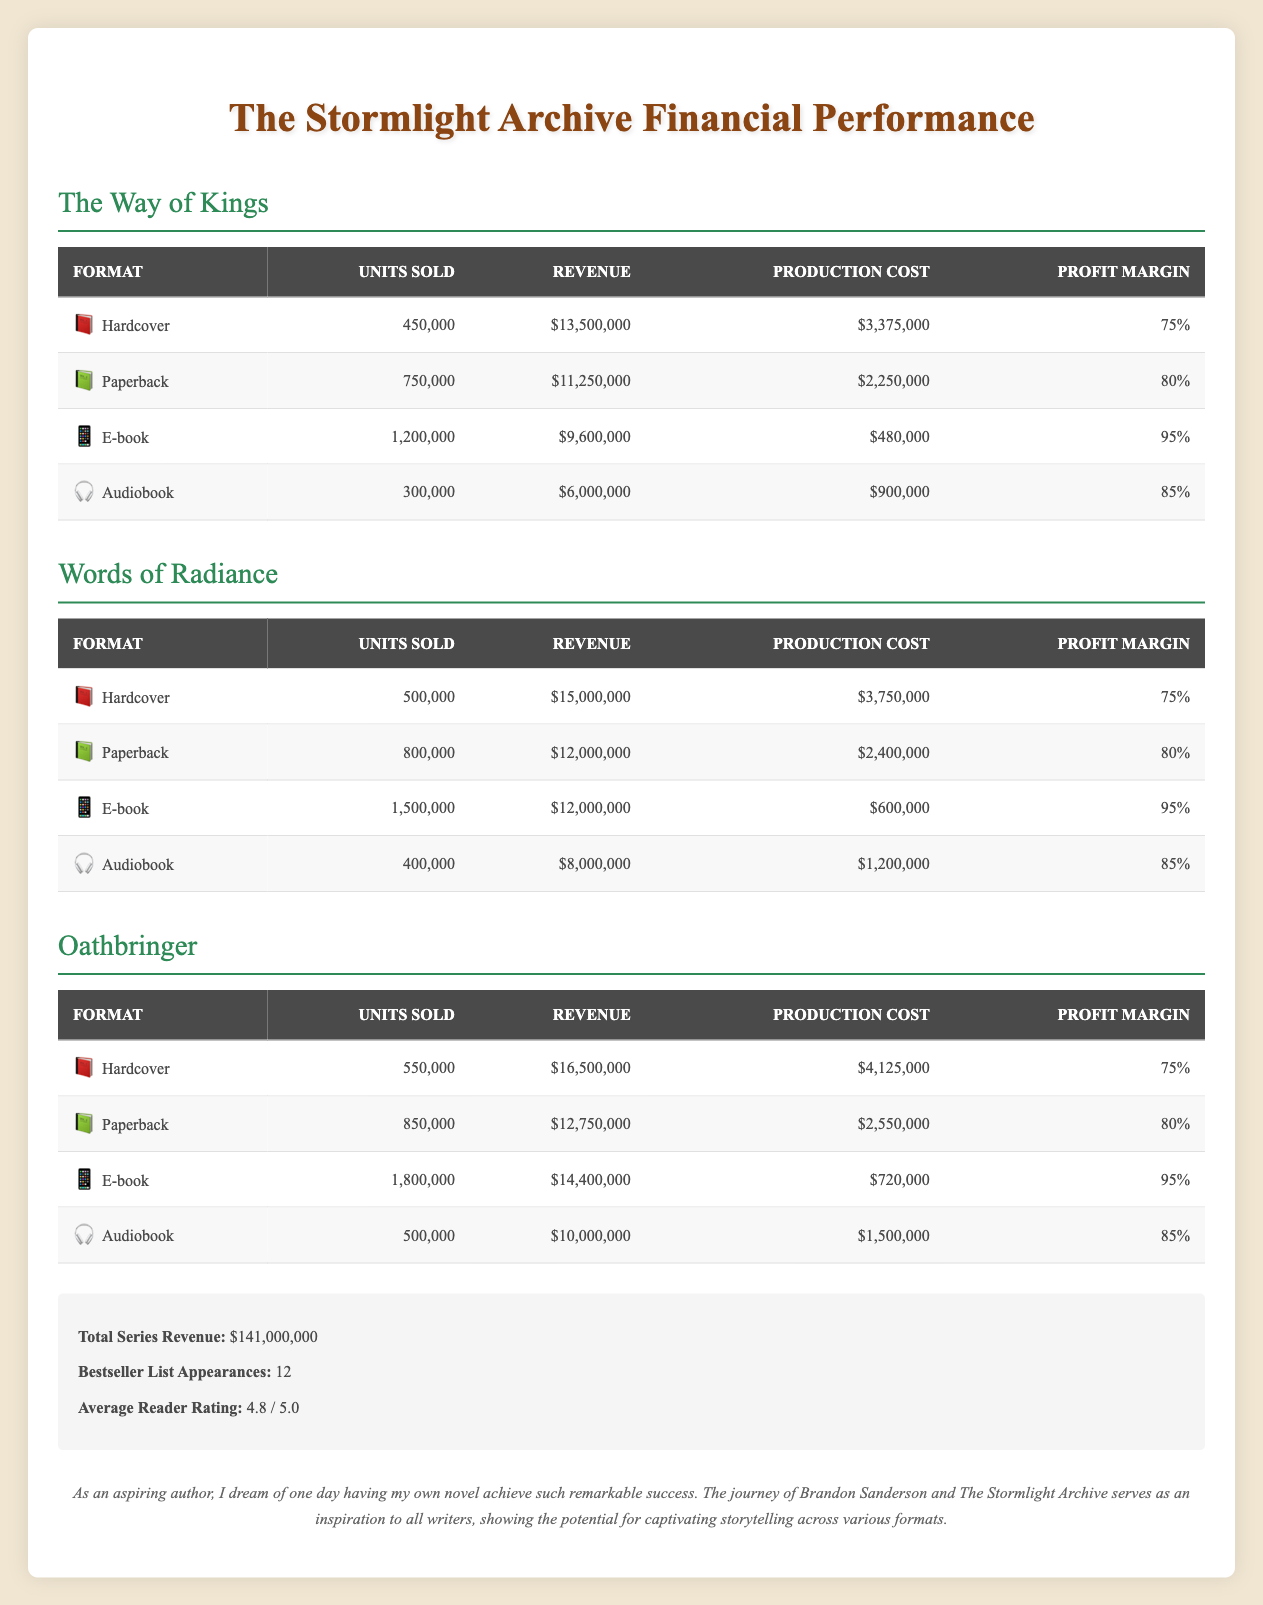What is the total revenue generated from the E-book format across all books? To find the total revenue from E-books, sum up the revenue from each book's E-book format: The Way of Kings ($9,600,000) + Words of Radiance ($12,000,000) + Oathbringer ($14,400,000). This gives us $9,600,000 + $12,000,000 + $14,400,000 = $36,000,000.
Answer: 36,000,000 Which format had the highest units sold for The Way of Kings? By looking at the units sold for each format in The Way of Kings, we see that Hardcover sold 450,000 units, Paperback sold 750,000 units, E-book sold 1,200,000 units, and Audiobook sold 300,000 units. E-book has the highest at 1,200,000 units sold.
Answer: E-book Is the profit margin for the Paperback format higher than that of the Audiobook format for Words of Radiance? The Paperback format for Words of Radiance has a profit margin of 80%, while the Audiobook format has a profit margin of 85%. Since 80% is not higher than 85%, the answer is no.
Answer: No What is the average production cost for all formats of Oathbringer? To calculate the average production cost, first sum the production costs of all formats for Oathbringer: Hardcover ($4,125,000) + Paperback ($2,550,000) + E-book ($720,000) + Audiobook ($1,500,000) = $8,895,000. There are 4 formats, so the average is $8,895,000 / 4 = $2,223,750.
Answer: 2,223,750 Did the Hardcover format of The Way of Kings generate more revenue than the Paperback format of Oathbringer? The revenue for the Hardcover of The Way of Kings is $13,500,000, while the revenue for the Paperback of Oathbringer is $12,750,000. Since $13,500,000 is greater than $12,750,000, the answer is yes.
Answer: Yes What is the total number of units sold across all formats for Words of Radiance? To find the total units sold for Words of Radiance, add up the units sold for each format: Hardcover (500,000) + Paperback (800,000) + E-book (1,500,000) + Audiobook (400,000) = 500,000 + 800,000 + 1,500,000 + 400,000 = 3,200,000.
Answer: 3,200,000 Which book had the lowest revenue, and what was the revenue amount? Comparing the total revenue from each book, The Way of Kings earned $11,250,000 (Paperback) as the lowest single format revenue. However, checking the overall revenue, The Way of Kings earned $13,500,000 (Hardcover) and comprises an essential consideration of all formats. In terms of lowest revenue across all formats, The Way of Kings' E-book format is lowest at $9,600,000. The answer focuses on that single lowest as a revenue amount rather than overall formats.
Answer: The Way of Kings, 9,600,000 What is the total units sold for Audiobooks across all books? To find the total number of units sold for Audiobooks, sum the units sold of the Audiobook format for each book: The Way of Kings (300,000) + Words of Radiance (400,000) + Oathbringer (500,000) = 300,000 + 400,000 + 500,000 = 1,200,000.
Answer: 1,200,000 